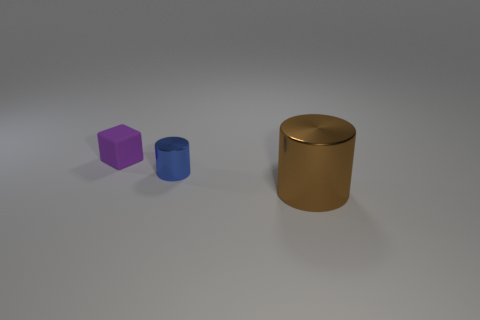Does the purple thing have the same material as the small thing that is in front of the matte block?
Provide a short and direct response. No. Are there fewer purple rubber objects to the right of the tiny blue metallic cylinder than big metal things in front of the brown thing?
Your answer should be very brief. No. What is the small blue object that is on the left side of the large brown metal object made of?
Provide a succinct answer. Metal. There is a object that is both behind the brown metallic thing and in front of the small rubber block; what is its color?
Offer a very short reply. Blue. What number of other objects are the same color as the small rubber object?
Provide a short and direct response. 0. There is a object that is behind the tiny blue cylinder; what color is it?
Give a very brief answer. Purple. Are there any matte cubes of the same size as the purple matte thing?
Offer a very short reply. No. There is a purple cube that is the same size as the blue thing; what is its material?
Give a very brief answer. Rubber. How many things are either metallic cylinders behind the brown shiny thing or small things that are behind the small blue metal cylinder?
Provide a succinct answer. 2. Are there any brown things of the same shape as the blue metallic object?
Your answer should be very brief. Yes. 